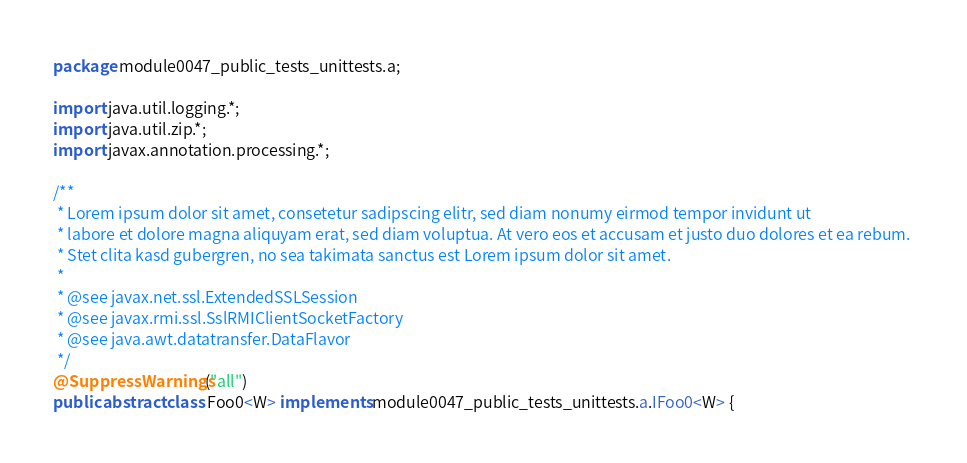<code> <loc_0><loc_0><loc_500><loc_500><_Java_>package module0047_public_tests_unittests.a;

import java.util.logging.*;
import java.util.zip.*;
import javax.annotation.processing.*;

/**
 * Lorem ipsum dolor sit amet, consetetur sadipscing elitr, sed diam nonumy eirmod tempor invidunt ut 
 * labore et dolore magna aliquyam erat, sed diam voluptua. At vero eos et accusam et justo duo dolores et ea rebum. 
 * Stet clita kasd gubergren, no sea takimata sanctus est Lorem ipsum dolor sit amet. 
 *
 * @see javax.net.ssl.ExtendedSSLSession
 * @see javax.rmi.ssl.SslRMIClientSocketFactory
 * @see java.awt.datatransfer.DataFlavor
 */
@SuppressWarnings("all")
public abstract class Foo0<W> implements module0047_public_tests_unittests.a.IFoo0<W> {
</code> 